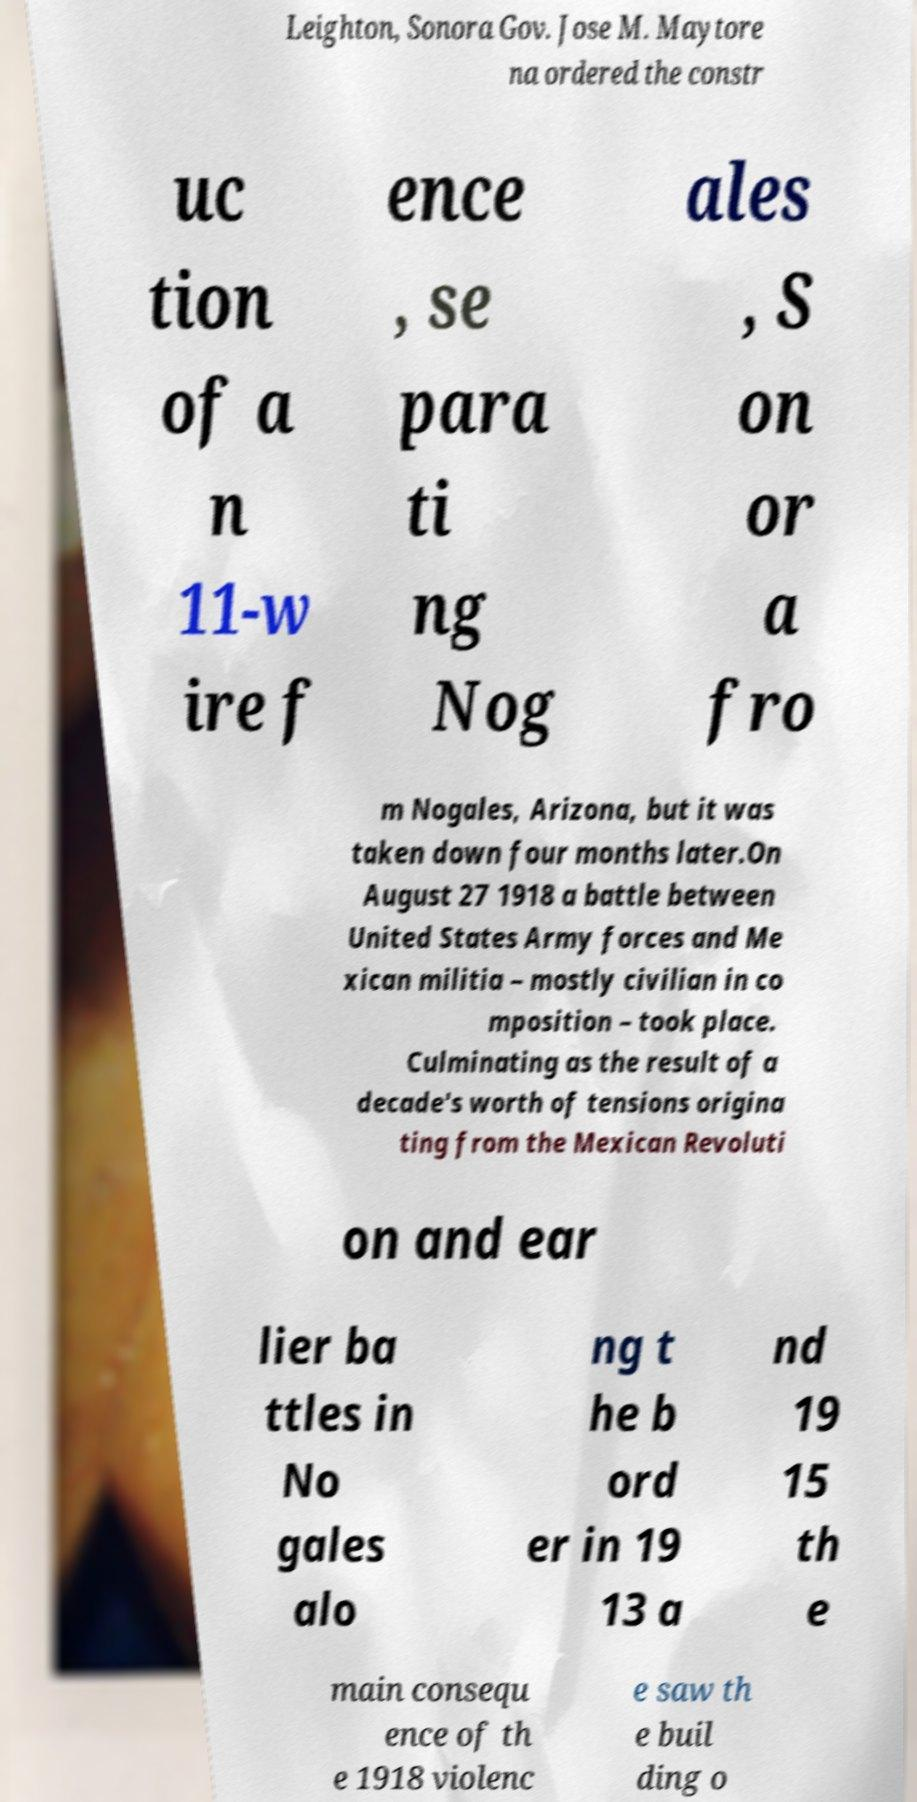Please read and relay the text visible in this image. What does it say? Leighton, Sonora Gov. Jose M. Maytore na ordered the constr uc tion of a n 11-w ire f ence , se para ti ng Nog ales , S on or a fro m Nogales, Arizona, but it was taken down four months later.On August 27 1918 a battle between United States Army forces and Me xican militia – mostly civilian in co mposition – took place. Culminating as the result of a decade's worth of tensions origina ting from the Mexican Revoluti on and ear lier ba ttles in No gales alo ng t he b ord er in 19 13 a nd 19 15 th e main consequ ence of th e 1918 violenc e saw th e buil ding o 